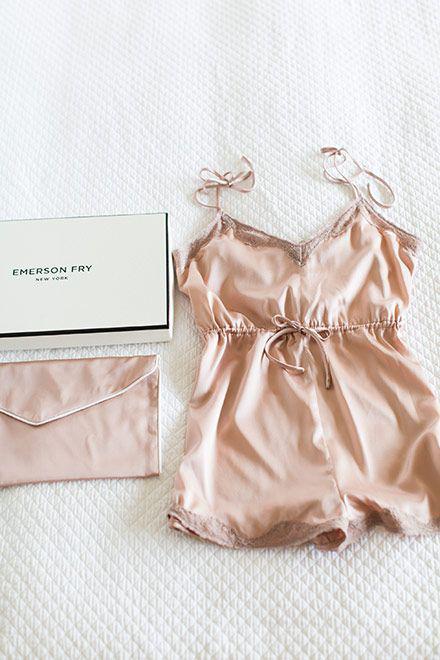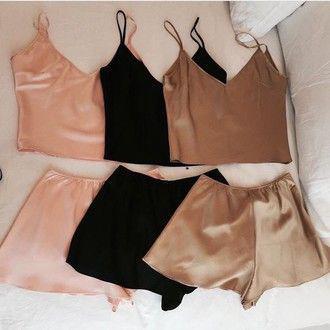The first image is the image on the left, the second image is the image on the right. Assess this claim about the two images: "At least one pajama is one piece and has a card or paper near it was a brand name.". Correct or not? Answer yes or no. Yes. The first image is the image on the left, the second image is the image on the right. For the images displayed, is the sentence "There is only one single piece outfit and only one two piece outfit." factually correct? Answer yes or no. No. 